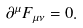Convert formula to latex. <formula><loc_0><loc_0><loc_500><loc_500>\partial ^ { \mu } F _ { \mu \nu } = 0 .</formula> 